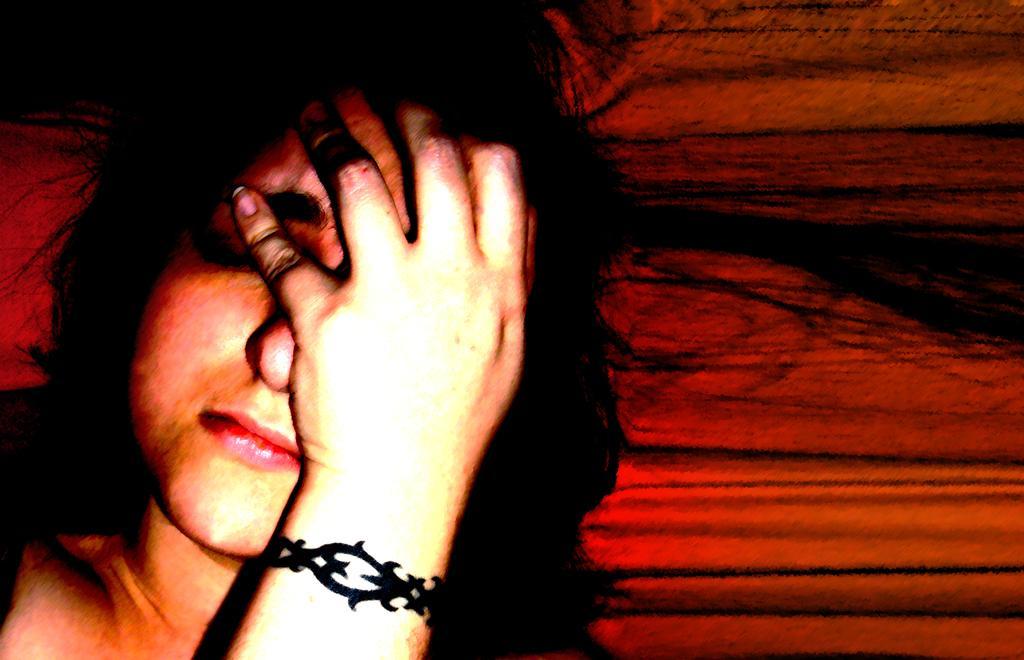Please provide a concise description of this image. In this image I can see the person. Background is in red and black color. 